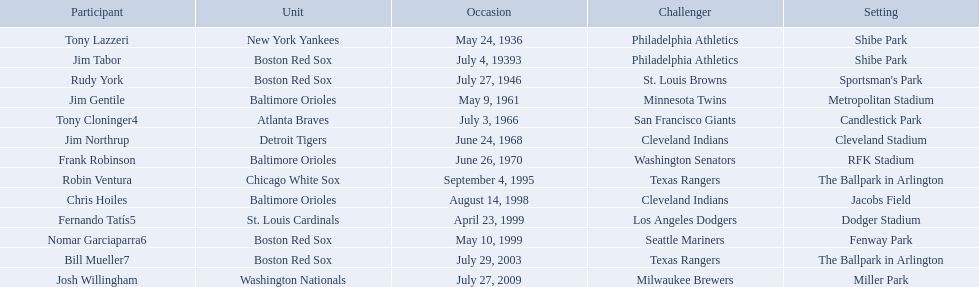Who are the opponents of the boston red sox during baseball home run records? Philadelphia Athletics, St. Louis Browns, Seattle Mariners, Texas Rangers. Of those which was the opponent on july 27, 1946? St. Louis Browns. What are the names of all the players? Tony Lazzeri, Jim Tabor, Rudy York, Jim Gentile, Tony Cloninger4, Jim Northrup, Frank Robinson, Robin Ventura, Chris Hoiles, Fernando Tatís5, Nomar Garciaparra6, Bill Mueller7, Josh Willingham. What are the names of all the teams holding home run records? New York Yankees, Boston Red Sox, Baltimore Orioles, Atlanta Braves, Detroit Tigers, Chicago White Sox, St. Louis Cardinals, Washington Nationals. Which player played for the new york yankees? Tony Lazzeri. Who were all of the players? Tony Lazzeri, Jim Tabor, Rudy York, Jim Gentile, Tony Cloninger4, Jim Northrup, Frank Robinson, Robin Ventura, Chris Hoiles, Fernando Tatís5, Nomar Garciaparra6, Bill Mueller7, Josh Willingham. What year was there a player for the yankees? May 24, 1936. What was the name of that 1936 yankees player? Tony Lazzeri. 